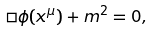<formula> <loc_0><loc_0><loc_500><loc_500>\Box \phi ( x ^ { \mu } ) + m ^ { 2 } = 0 ,</formula> 